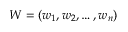<formula> <loc_0><loc_0><loc_500><loc_500>W = ( w _ { 1 } , w _ { 2 } , \dots , w _ { n } )</formula> 